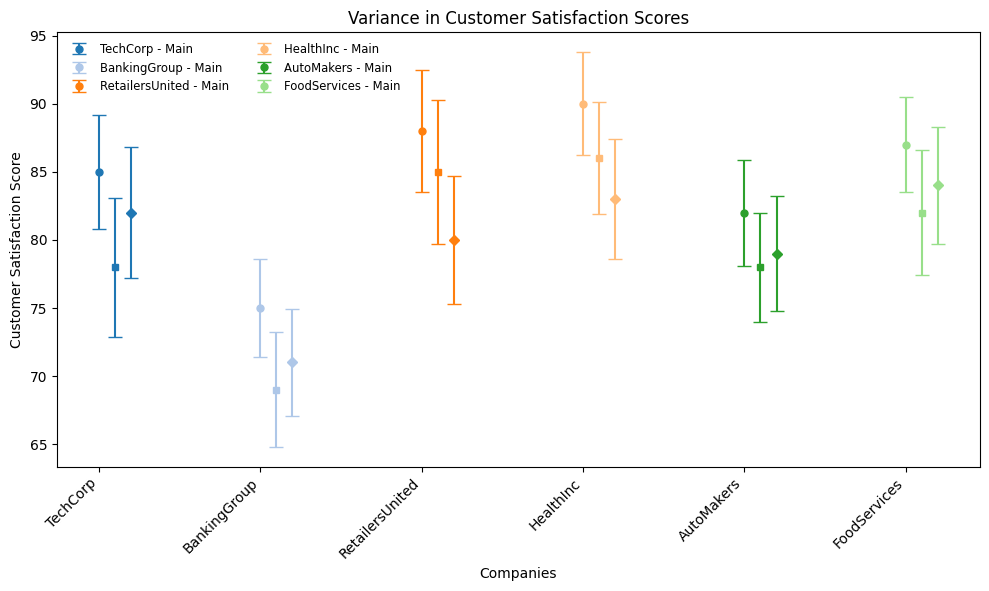Which company has the highest main customer satisfaction score? The figure shows customer satisfaction scores of main companies and their subsidiaries. The main entity of HealthInc in the Healthcare industry has the highest customer satisfaction score of 90.
Answer: HealthInc How does the satisfaction score of TechCorp’s Main company compare to that of TechCorp’s Subsidiary A? By observing the plotted scores, the satisfaction score of TechCorp’s Main company is 85, while that of Subsidiary A is 78. The Main company's score is 7 points higher than Subsidiary A's.
Answer: TechCorp’s Main company has a higher score by 7 points Between BankingGroup’s main company and its subsidiaries, which entity has the lowest standard deviation in satisfaction scores? From the figure, compare the error bars (standard deviations) for Main, Subsidiary A, and Subsidiary B of BankingGroup. The main company has the lowest standard deviation of 3.6.
Answer: The main company What is the average customer satisfaction score for RetailersUnited’s entities? RetailersUnited has three entities: Main (88), Subsidiary A (85), and Subsidiary B (80). The average score is calculated as (88+85+80)/3 = 84.33.
Answer: 84.33 Which industry exhibits the smallest variation in customer satisfaction scores among its companies and subsidiaries? The smallest variation would be indicated by the shortest error bars collectively. By observing, the Automotive industry (AutoMakers) shows consistently short error bars.
Answer: Automotive Compare the standard deviations of satisfaction scores between FoodServices’ main company and Subsidiary B. Which one is lower? From the figure, the standard deviation for FoodServices' main company is 3.5 and for Subsidiary B it is 4.3. The main company's standard deviation is lower.
Answer: FoodServices' main company Do any subsidiaries outperform their main companies in terms of customer satisfaction scores? If so, which ones? By comparing the plotted scores, no subsidiary shows a higher satisfaction score than its corresponding main company. All main companies have the highest scores among their entities.
Answer: No How much lower is AutoMakers’ Subsidiary A’s customer satisfaction score compared to HealthInc’s Main score? AutoMakers' Subsidiary A’s score is 78 and HealthInc’s Main score is 90. The difference is 90 - 78 = 12.
Answer: 12 points Which company-subsidiary pair has the largest difference in customer satisfaction scores? By checking the plotted differences, BankingGroup’s Main and Subsidiary A have a large difference. Main is 75 and Subsidiary A is 69, yielding a difference of 6 points. Other pairs have smaller differences.
Answer: BankingGroup 